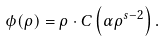Convert formula to latex. <formula><loc_0><loc_0><loc_500><loc_500>\phi ( \rho ) = \rho \cdot C \left ( \alpha \rho ^ { s - 2 } \right ) .</formula> 